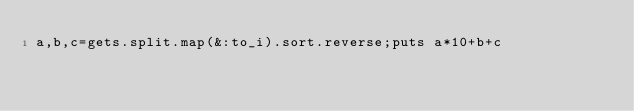Convert code to text. <code><loc_0><loc_0><loc_500><loc_500><_Ruby_>a,b,c=gets.split.map(&:to_i).sort.reverse;puts a*10+b+c</code> 